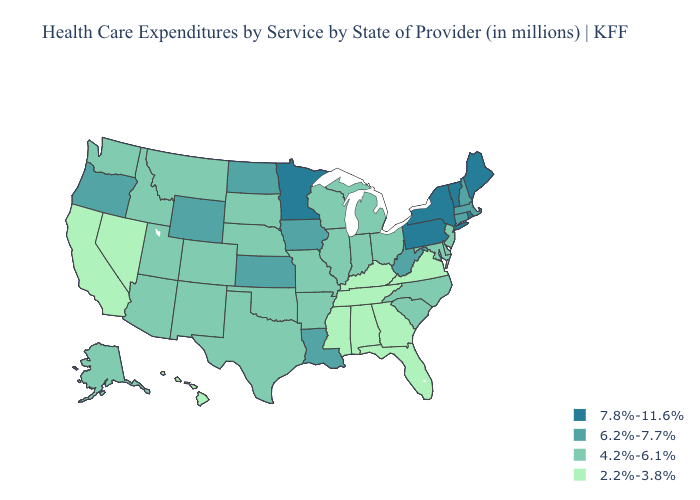How many symbols are there in the legend?
Answer briefly. 4. Which states have the lowest value in the USA?
Give a very brief answer. Alabama, California, Florida, Georgia, Hawaii, Kentucky, Mississippi, Nevada, Tennessee, Virginia. Does Kentucky have the highest value in the South?
Give a very brief answer. No. Name the states that have a value in the range 4.2%-6.1%?
Give a very brief answer. Alaska, Arizona, Arkansas, Colorado, Delaware, Idaho, Illinois, Indiana, Maryland, Michigan, Missouri, Montana, Nebraska, New Jersey, New Mexico, North Carolina, Ohio, Oklahoma, South Carolina, South Dakota, Texas, Utah, Washington, Wisconsin. Name the states that have a value in the range 6.2%-7.7%?
Keep it brief. Connecticut, Iowa, Kansas, Louisiana, Massachusetts, New Hampshire, North Dakota, Oregon, West Virginia, Wyoming. Name the states that have a value in the range 4.2%-6.1%?
Concise answer only. Alaska, Arizona, Arkansas, Colorado, Delaware, Idaho, Illinois, Indiana, Maryland, Michigan, Missouri, Montana, Nebraska, New Jersey, New Mexico, North Carolina, Ohio, Oklahoma, South Carolina, South Dakota, Texas, Utah, Washington, Wisconsin. What is the value of South Carolina?
Quick response, please. 4.2%-6.1%. What is the value of Hawaii?
Keep it brief. 2.2%-3.8%. Among the states that border Maryland , does Delaware have the lowest value?
Write a very short answer. No. Name the states that have a value in the range 4.2%-6.1%?
Give a very brief answer. Alaska, Arizona, Arkansas, Colorado, Delaware, Idaho, Illinois, Indiana, Maryland, Michigan, Missouri, Montana, Nebraska, New Jersey, New Mexico, North Carolina, Ohio, Oklahoma, South Carolina, South Dakota, Texas, Utah, Washington, Wisconsin. Name the states that have a value in the range 6.2%-7.7%?
Be succinct. Connecticut, Iowa, Kansas, Louisiana, Massachusetts, New Hampshire, North Dakota, Oregon, West Virginia, Wyoming. What is the value of California?
Give a very brief answer. 2.2%-3.8%. Does California have the lowest value in the West?
Answer briefly. Yes. What is the value of New Mexico?
Short answer required. 4.2%-6.1%. What is the value of Delaware?
Short answer required. 4.2%-6.1%. 